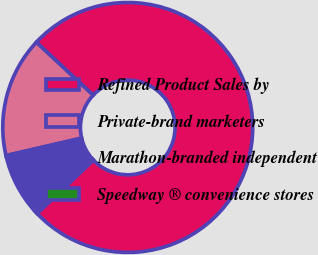Convert chart to OTSL. <chart><loc_0><loc_0><loc_500><loc_500><pie_chart><fcel>Refined Product Sales by<fcel>Private-brand marketers<fcel>Marathon-branded independent<fcel>Speedway ® convenience stores<nl><fcel>75.98%<fcel>15.56%<fcel>8.01%<fcel>0.45%<nl></chart> 